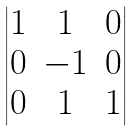<formula> <loc_0><loc_0><loc_500><loc_500>\begin{vmatrix} 1 & 1 & 0 \\ 0 & - 1 & 0 \\ 0 & 1 & 1 \\ \end{vmatrix}</formula> 